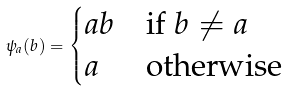Convert formula to latex. <formula><loc_0><loc_0><loc_500><loc_500>\psi _ { a } ( b ) = \begin{cases} a b & \text {if $b\ne a$} \\ a & \text {otherwise} \end{cases}</formula> 